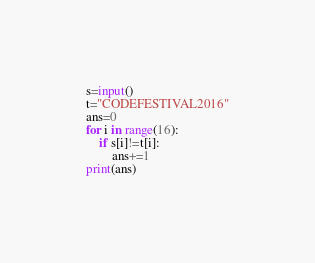<code> <loc_0><loc_0><loc_500><loc_500><_Python_>s=input()
t="CODEFESTIVAL2016"
ans=0
for i in range(16):
    if s[i]!=t[i]:
        ans+=1
print(ans)</code> 